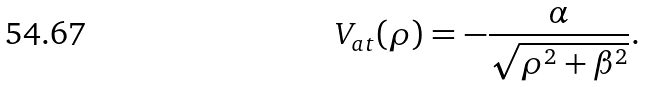<formula> <loc_0><loc_0><loc_500><loc_500>V _ { a t } ( \rho ) = - \frac { \alpha } { \sqrt { \rho ^ { 2 } + \beta ^ { 2 } } } .</formula> 